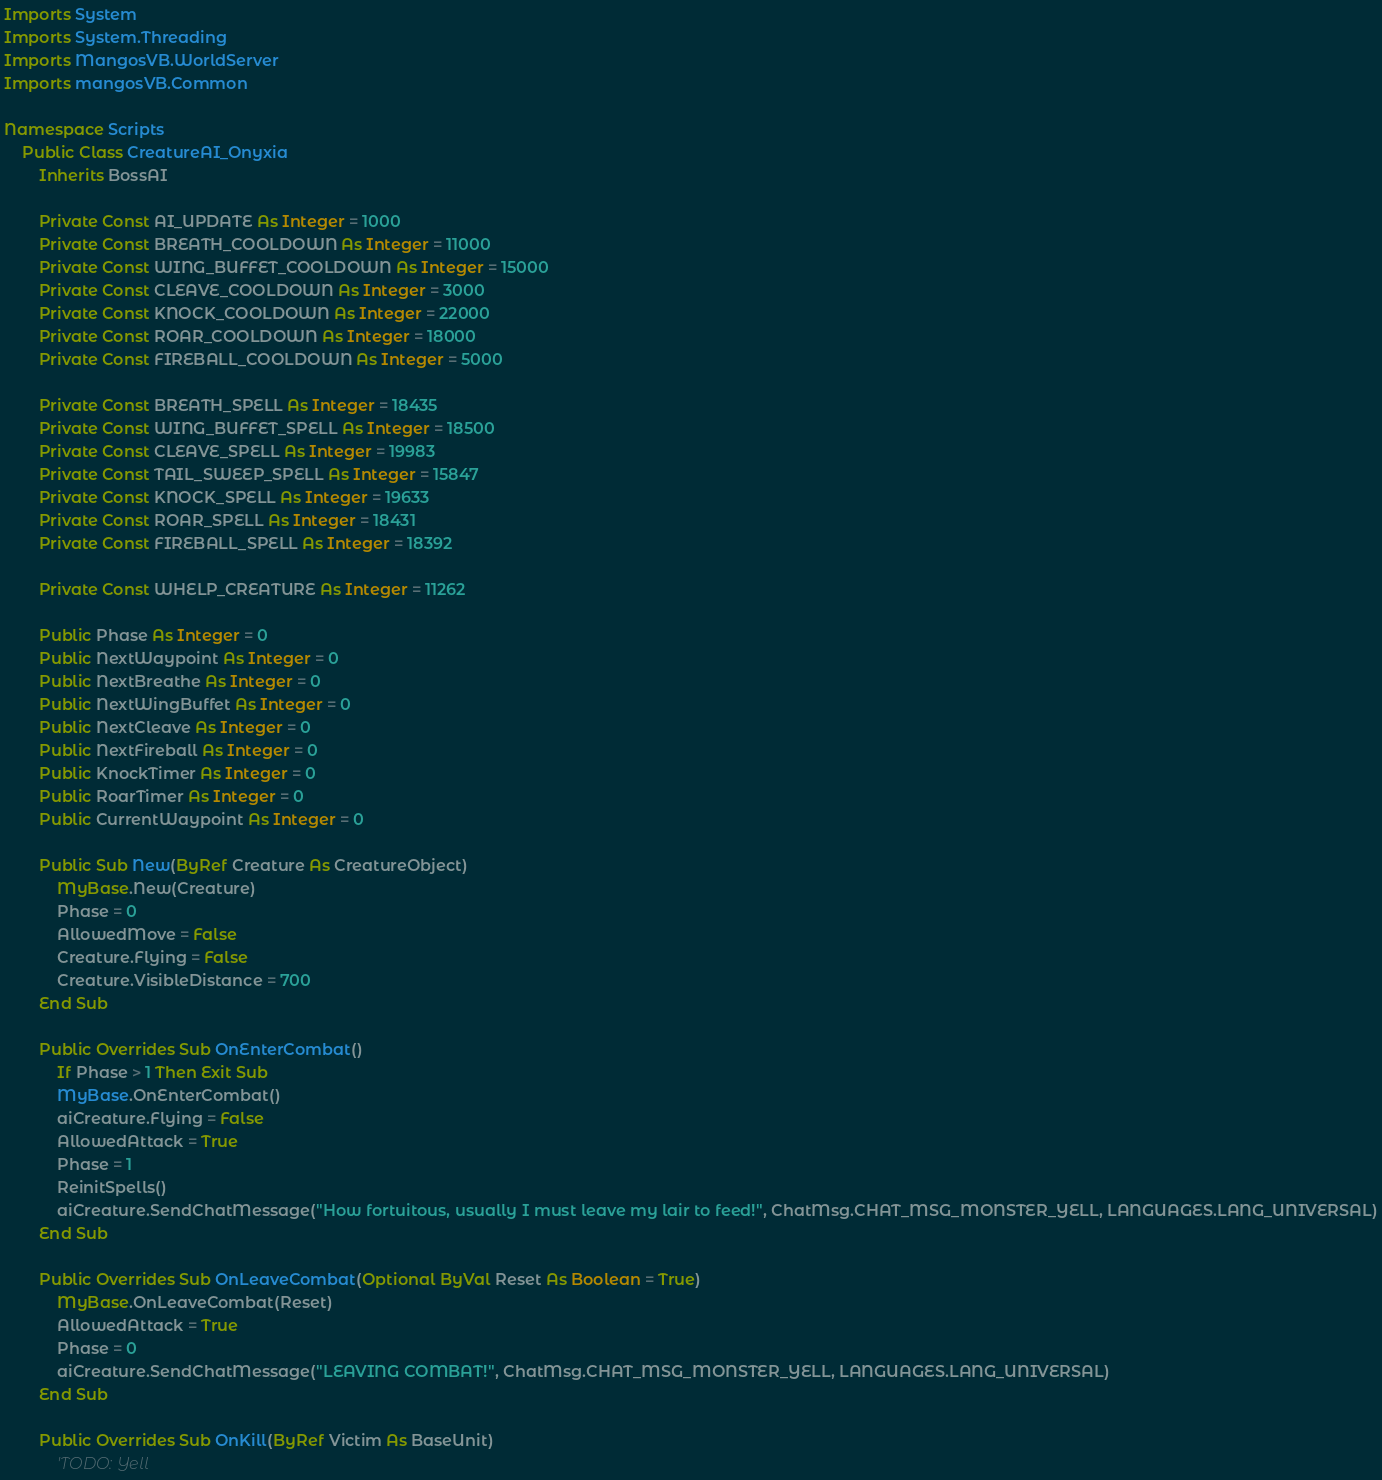Convert code to text. <code><loc_0><loc_0><loc_500><loc_500><_VisualBasic_>Imports System
Imports System.Threading
Imports MangosVB.WorldServer
Imports mangosVB.Common

Namespace Scripts
    Public Class CreatureAI_Onyxia
        Inherits BossAI

        Private Const AI_UPDATE As Integer = 1000
        Private Const BREATH_COOLDOWN As Integer = 11000
        Private Const WING_BUFFET_COOLDOWN As Integer = 15000
        Private Const CLEAVE_COOLDOWN As Integer = 3000
        Private Const KNOCK_COOLDOWN As Integer = 22000
        Private Const ROAR_COOLDOWN As Integer = 18000
        Private Const FIREBALL_COOLDOWN As Integer = 5000

        Private Const BREATH_SPELL As Integer = 18435
        Private Const WING_BUFFET_SPELL As Integer = 18500
        Private Const CLEAVE_SPELL As Integer = 19983
        Private Const TAIL_SWEEP_SPELL As Integer = 15847
        Private Const KNOCK_SPELL As Integer = 19633
        Private Const ROAR_SPELL As Integer = 18431
        Private Const FIREBALL_SPELL As Integer = 18392

        Private Const WHELP_CREATURE As Integer = 11262

        Public Phase As Integer = 0
        Public NextWaypoint As Integer = 0
        Public NextBreathe As Integer = 0
        Public NextWingBuffet As Integer = 0
        Public NextCleave As Integer = 0
        Public NextFireball As Integer = 0
        Public KnockTimer As Integer = 0
        Public RoarTimer As Integer = 0
        Public CurrentWaypoint As Integer = 0

        Public Sub New(ByRef Creature As CreatureObject)
            MyBase.New(Creature)
            Phase = 0
            AllowedMove = False
            Creature.Flying = False
            Creature.VisibleDistance = 700
        End Sub

        Public Overrides Sub OnEnterCombat()
            If Phase > 1 Then Exit Sub
            MyBase.OnEnterCombat()
            aiCreature.Flying = False
            AllowedAttack = True
            Phase = 1
            ReinitSpells()
            aiCreature.SendChatMessage("How fortuitous, usually I must leave my lair to feed!", ChatMsg.CHAT_MSG_MONSTER_YELL, LANGUAGES.LANG_UNIVERSAL)
        End Sub

        Public Overrides Sub OnLeaveCombat(Optional ByVal Reset As Boolean = True)
            MyBase.OnLeaveCombat(Reset)
            AllowedAttack = True
            Phase = 0
            aiCreature.SendChatMessage("LEAVING COMBAT!", ChatMsg.CHAT_MSG_MONSTER_YELL, LANGUAGES.LANG_UNIVERSAL)
        End Sub

        Public Overrides Sub OnKill(ByRef Victim As BaseUnit)
            'TODO: Yell</code> 